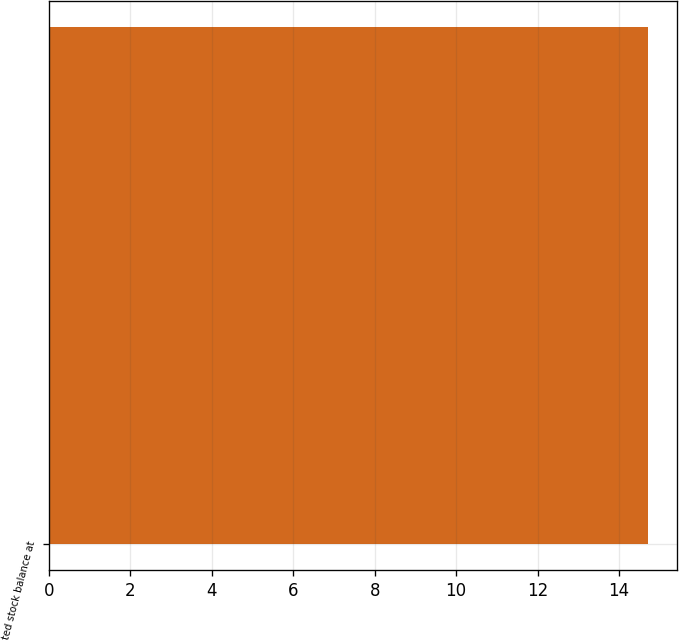Convert chart. <chart><loc_0><loc_0><loc_500><loc_500><bar_chart><fcel>Restricted stock balance at<nl><fcel>14.7<nl></chart> 